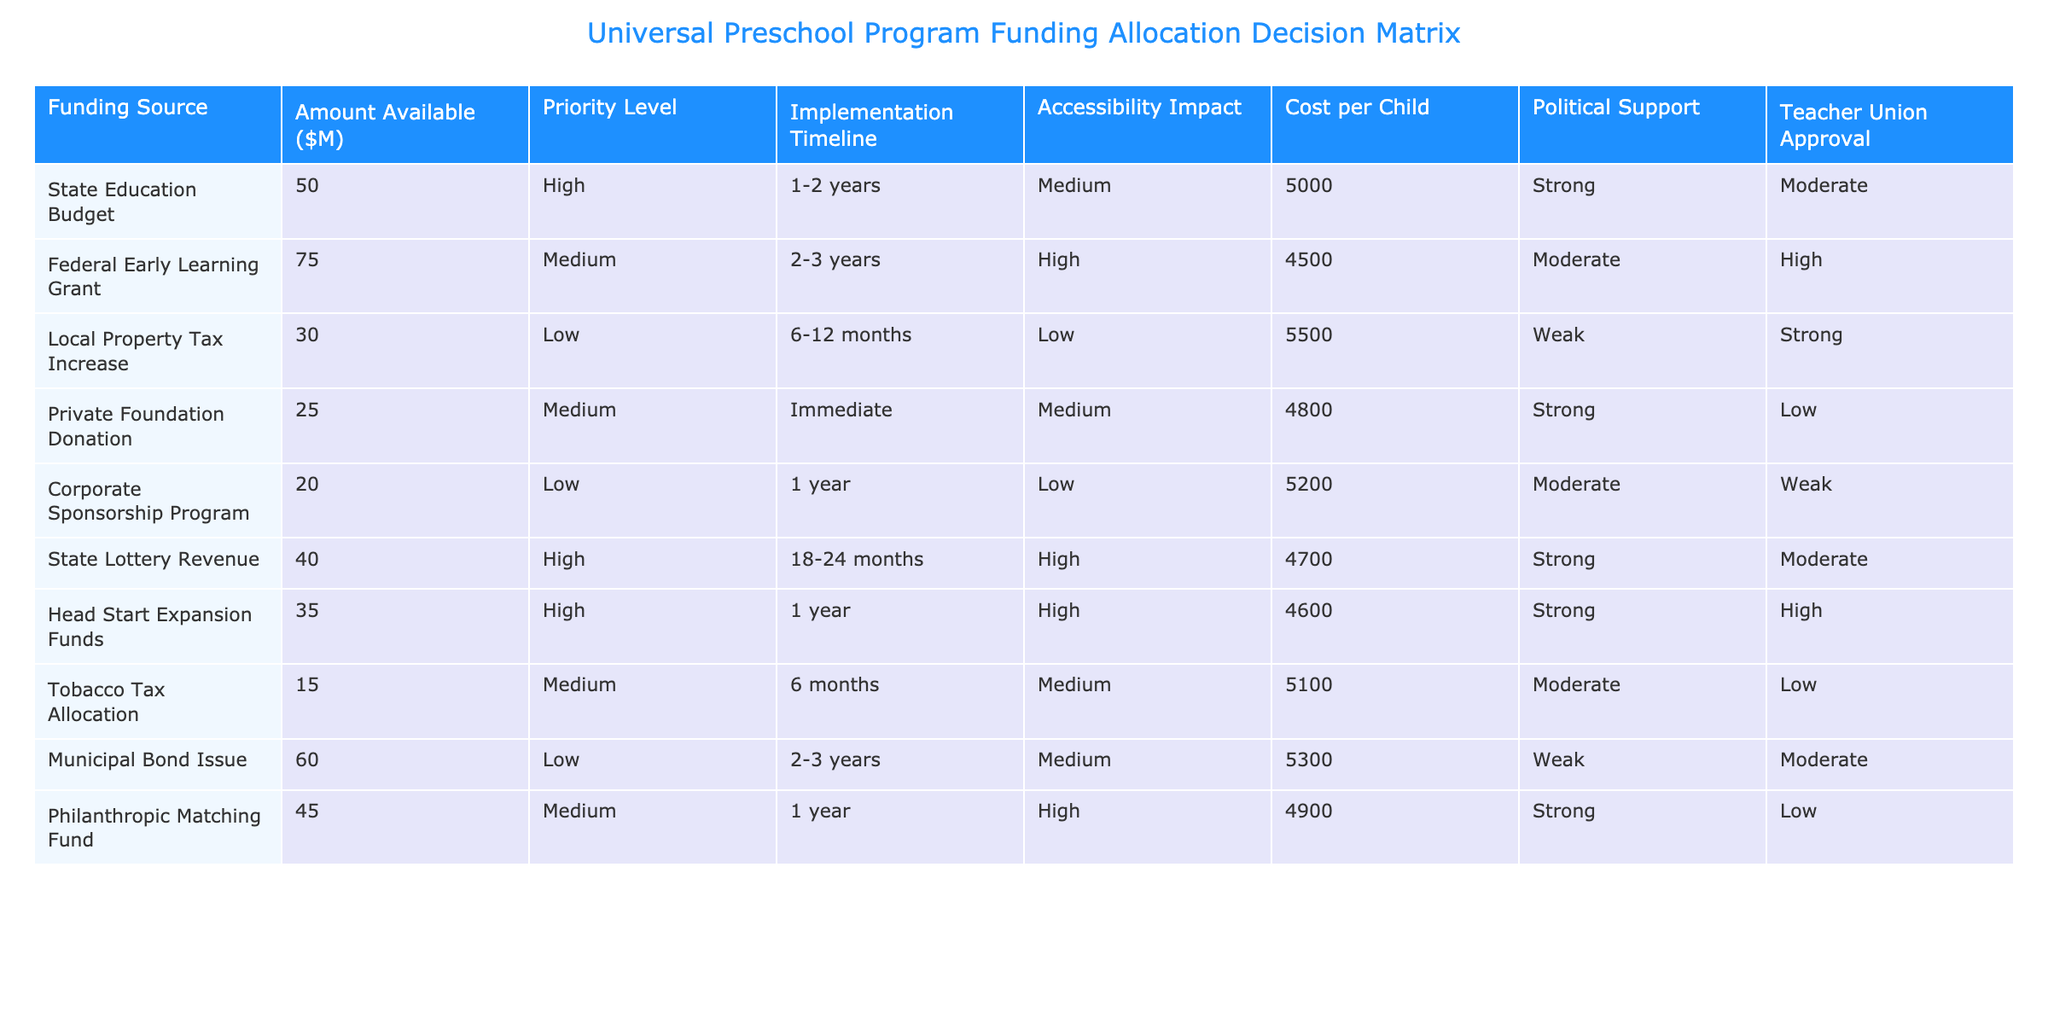What is the highest amount available from a single funding source? According to the table, the highest amount available from a single funding source is 75M from the Federal Early Learning Grant.
Answer: 75M Which funding source has the lowest political support? Reviewing the table, the funding source with the lowest political support is the Corporate Sponsorship Program, which has weak support.
Answer: Corporate Sponsorship Program What is the total amount available for funding from high-priority sources? The high-priority sources are the State Education Budget (50M), State Lottery Revenue (40M), and Head Start Expansion Funds (35M). Adding these gives 50 + 40 + 35 = 125M.
Answer: 125M Is there a funding source with immediate implementation that also has strong teacher union approval? The Private Foundation Donation is the only source with immediate implementation and it has strong teacher union approval.
Answer: No What is the average cost per child for all funding sources? Summing the costs per child from all sources gives 5000 + 4500 + 5500 + 4800 + 5200 + 4700 + 4600 + 5100 + 5300 + 4900 = 52000. There are 10 funding sources, so 52000/10 = 5200.
Answer: 5200 Which funding sources provide high accessibility impact, and what is the total amount available from these sources? The funding sources with high accessibility impact are Federal Early Learning Grant (75M), State Lottery Revenue (40M), Head Start Expansion Funds (35M), and Philanthropic Matching Fund (45M). Adding these gives 75 + 40 + 35 + 45 = 195M.
Answer: 195M Is the Local Property Tax Increase the only option with low accessibility impact? Comparing the table, the Local Property Tax Increase is not the only option with low accessibility impact; the Corporate Sponsorship Program and Municipal Bond Issue also fall into this category.
Answer: No What is the priority level of the Tobacco Tax Allocation funding source? The Tobacco Tax Allocation has a medium priority level according to the table.
Answer: Medium How many funding sources are categorized as low priority? The table indicates there are three sources categorized as low priority: Local Property Tax Increase, Corporate Sponsorship Program, and Municipal Bond Issue.
Answer: 3 